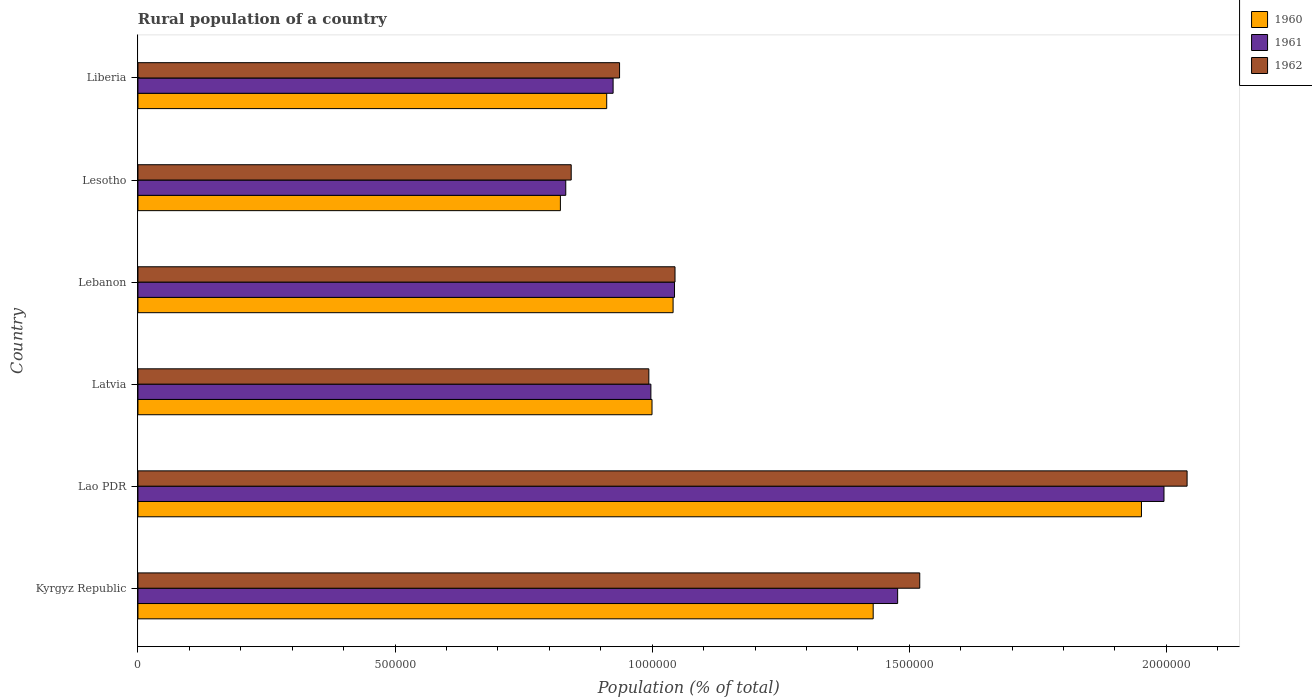Are the number of bars per tick equal to the number of legend labels?
Offer a very short reply. Yes. What is the label of the 4th group of bars from the top?
Provide a succinct answer. Latvia. In how many cases, is the number of bars for a given country not equal to the number of legend labels?
Your answer should be compact. 0. What is the rural population in 1960 in Lesotho?
Your answer should be compact. 8.22e+05. Across all countries, what is the maximum rural population in 1962?
Ensure brevity in your answer.  2.04e+06. Across all countries, what is the minimum rural population in 1960?
Offer a terse response. 8.22e+05. In which country was the rural population in 1961 maximum?
Your answer should be very brief. Lao PDR. In which country was the rural population in 1961 minimum?
Keep it short and to the point. Lesotho. What is the total rural population in 1961 in the graph?
Provide a short and direct response. 7.27e+06. What is the difference between the rural population in 1961 in Kyrgyz Republic and that in Latvia?
Your response must be concise. 4.80e+05. What is the difference between the rural population in 1960 in Lesotho and the rural population in 1962 in Lao PDR?
Provide a short and direct response. -1.22e+06. What is the average rural population in 1960 per country?
Offer a very short reply. 1.19e+06. What is the difference between the rural population in 1961 and rural population in 1960 in Lao PDR?
Ensure brevity in your answer.  4.38e+04. What is the ratio of the rural population in 1960 in Kyrgyz Republic to that in Lebanon?
Your answer should be compact. 1.37. Is the rural population in 1962 in Kyrgyz Republic less than that in Lao PDR?
Offer a terse response. Yes. Is the difference between the rural population in 1961 in Lao PDR and Liberia greater than the difference between the rural population in 1960 in Lao PDR and Liberia?
Provide a short and direct response. Yes. What is the difference between the highest and the second highest rural population in 1961?
Your answer should be compact. 5.18e+05. What is the difference between the highest and the lowest rural population in 1961?
Your response must be concise. 1.16e+06. In how many countries, is the rural population in 1960 greater than the average rural population in 1960 taken over all countries?
Keep it short and to the point. 2. Is the sum of the rural population in 1961 in Kyrgyz Republic and Lebanon greater than the maximum rural population in 1962 across all countries?
Offer a very short reply. Yes. Is it the case that in every country, the sum of the rural population in 1961 and rural population in 1960 is greater than the rural population in 1962?
Your answer should be very brief. Yes. How many countries are there in the graph?
Your answer should be very brief. 6. What is the difference between two consecutive major ticks on the X-axis?
Offer a very short reply. 5.00e+05. Does the graph contain grids?
Offer a very short reply. No. How are the legend labels stacked?
Offer a very short reply. Vertical. What is the title of the graph?
Your response must be concise. Rural population of a country. Does "1972" appear as one of the legend labels in the graph?
Keep it short and to the point. No. What is the label or title of the X-axis?
Offer a terse response. Population (% of total). What is the Population (% of total) in 1960 in Kyrgyz Republic?
Your answer should be very brief. 1.43e+06. What is the Population (% of total) in 1961 in Kyrgyz Republic?
Offer a very short reply. 1.48e+06. What is the Population (% of total) in 1962 in Kyrgyz Republic?
Offer a very short reply. 1.52e+06. What is the Population (% of total) in 1960 in Lao PDR?
Keep it short and to the point. 1.95e+06. What is the Population (% of total) in 1961 in Lao PDR?
Offer a terse response. 2.00e+06. What is the Population (% of total) of 1962 in Lao PDR?
Ensure brevity in your answer.  2.04e+06. What is the Population (% of total) of 1960 in Latvia?
Offer a very short reply. 1.00e+06. What is the Population (% of total) of 1961 in Latvia?
Your response must be concise. 9.97e+05. What is the Population (% of total) in 1962 in Latvia?
Offer a very short reply. 9.94e+05. What is the Population (% of total) of 1960 in Lebanon?
Ensure brevity in your answer.  1.04e+06. What is the Population (% of total) of 1961 in Lebanon?
Ensure brevity in your answer.  1.04e+06. What is the Population (% of total) in 1962 in Lebanon?
Keep it short and to the point. 1.04e+06. What is the Population (% of total) of 1960 in Lesotho?
Your answer should be very brief. 8.22e+05. What is the Population (% of total) in 1961 in Lesotho?
Your answer should be very brief. 8.32e+05. What is the Population (% of total) of 1962 in Lesotho?
Your answer should be very brief. 8.43e+05. What is the Population (% of total) in 1960 in Liberia?
Provide a succinct answer. 9.12e+05. What is the Population (% of total) in 1961 in Liberia?
Offer a terse response. 9.24e+05. What is the Population (% of total) of 1962 in Liberia?
Offer a very short reply. 9.37e+05. Across all countries, what is the maximum Population (% of total) in 1960?
Offer a terse response. 1.95e+06. Across all countries, what is the maximum Population (% of total) of 1961?
Provide a short and direct response. 2.00e+06. Across all countries, what is the maximum Population (% of total) of 1962?
Your answer should be very brief. 2.04e+06. Across all countries, what is the minimum Population (% of total) of 1960?
Offer a terse response. 8.22e+05. Across all countries, what is the minimum Population (% of total) in 1961?
Offer a very short reply. 8.32e+05. Across all countries, what is the minimum Population (% of total) in 1962?
Provide a short and direct response. 8.43e+05. What is the total Population (% of total) in 1960 in the graph?
Your response must be concise. 7.15e+06. What is the total Population (% of total) of 1961 in the graph?
Keep it short and to the point. 7.27e+06. What is the total Population (% of total) in 1962 in the graph?
Your response must be concise. 7.38e+06. What is the difference between the Population (% of total) in 1960 in Kyrgyz Republic and that in Lao PDR?
Your answer should be very brief. -5.22e+05. What is the difference between the Population (% of total) in 1961 in Kyrgyz Republic and that in Lao PDR?
Offer a terse response. -5.18e+05. What is the difference between the Population (% of total) of 1962 in Kyrgyz Republic and that in Lao PDR?
Offer a terse response. -5.20e+05. What is the difference between the Population (% of total) in 1960 in Kyrgyz Republic and that in Latvia?
Provide a succinct answer. 4.30e+05. What is the difference between the Population (% of total) in 1961 in Kyrgyz Republic and that in Latvia?
Offer a terse response. 4.80e+05. What is the difference between the Population (% of total) of 1962 in Kyrgyz Republic and that in Latvia?
Give a very brief answer. 5.27e+05. What is the difference between the Population (% of total) in 1960 in Kyrgyz Republic and that in Lebanon?
Your answer should be compact. 3.89e+05. What is the difference between the Population (% of total) in 1961 in Kyrgyz Republic and that in Lebanon?
Give a very brief answer. 4.34e+05. What is the difference between the Population (% of total) in 1962 in Kyrgyz Republic and that in Lebanon?
Your answer should be very brief. 4.76e+05. What is the difference between the Population (% of total) of 1960 in Kyrgyz Republic and that in Lesotho?
Your response must be concise. 6.08e+05. What is the difference between the Population (% of total) in 1961 in Kyrgyz Republic and that in Lesotho?
Provide a succinct answer. 6.45e+05. What is the difference between the Population (% of total) in 1962 in Kyrgyz Republic and that in Lesotho?
Your answer should be compact. 6.78e+05. What is the difference between the Population (% of total) in 1960 in Kyrgyz Republic and that in Liberia?
Your answer should be very brief. 5.18e+05. What is the difference between the Population (% of total) in 1961 in Kyrgyz Republic and that in Liberia?
Provide a succinct answer. 5.53e+05. What is the difference between the Population (% of total) in 1962 in Kyrgyz Republic and that in Liberia?
Make the answer very short. 5.84e+05. What is the difference between the Population (% of total) in 1960 in Lao PDR and that in Latvia?
Offer a terse response. 9.52e+05. What is the difference between the Population (% of total) in 1961 in Lao PDR and that in Latvia?
Offer a terse response. 9.98e+05. What is the difference between the Population (% of total) of 1962 in Lao PDR and that in Latvia?
Your answer should be compact. 1.05e+06. What is the difference between the Population (% of total) of 1960 in Lao PDR and that in Lebanon?
Provide a short and direct response. 9.11e+05. What is the difference between the Population (% of total) of 1961 in Lao PDR and that in Lebanon?
Provide a short and direct response. 9.52e+05. What is the difference between the Population (% of total) of 1962 in Lao PDR and that in Lebanon?
Give a very brief answer. 9.96e+05. What is the difference between the Population (% of total) of 1960 in Lao PDR and that in Lesotho?
Provide a succinct answer. 1.13e+06. What is the difference between the Population (% of total) in 1961 in Lao PDR and that in Lesotho?
Your answer should be very brief. 1.16e+06. What is the difference between the Population (% of total) in 1962 in Lao PDR and that in Lesotho?
Provide a succinct answer. 1.20e+06. What is the difference between the Population (% of total) in 1960 in Lao PDR and that in Liberia?
Your answer should be very brief. 1.04e+06. What is the difference between the Population (% of total) in 1961 in Lao PDR and that in Liberia?
Keep it short and to the point. 1.07e+06. What is the difference between the Population (% of total) in 1962 in Lao PDR and that in Liberia?
Give a very brief answer. 1.10e+06. What is the difference between the Population (% of total) in 1960 in Latvia and that in Lebanon?
Make the answer very short. -4.10e+04. What is the difference between the Population (% of total) of 1961 in Latvia and that in Lebanon?
Ensure brevity in your answer.  -4.60e+04. What is the difference between the Population (% of total) of 1962 in Latvia and that in Lebanon?
Offer a terse response. -5.09e+04. What is the difference between the Population (% of total) in 1960 in Latvia and that in Lesotho?
Give a very brief answer. 1.78e+05. What is the difference between the Population (% of total) in 1961 in Latvia and that in Lesotho?
Offer a very short reply. 1.66e+05. What is the difference between the Population (% of total) of 1962 in Latvia and that in Lesotho?
Make the answer very short. 1.51e+05. What is the difference between the Population (% of total) in 1960 in Latvia and that in Liberia?
Keep it short and to the point. 8.81e+04. What is the difference between the Population (% of total) in 1961 in Latvia and that in Liberia?
Your answer should be very brief. 7.35e+04. What is the difference between the Population (% of total) of 1962 in Latvia and that in Liberia?
Give a very brief answer. 5.69e+04. What is the difference between the Population (% of total) of 1960 in Lebanon and that in Lesotho?
Offer a terse response. 2.19e+05. What is the difference between the Population (% of total) of 1961 in Lebanon and that in Lesotho?
Keep it short and to the point. 2.12e+05. What is the difference between the Population (% of total) of 1962 in Lebanon and that in Lesotho?
Make the answer very short. 2.02e+05. What is the difference between the Population (% of total) in 1960 in Lebanon and that in Liberia?
Offer a terse response. 1.29e+05. What is the difference between the Population (% of total) of 1961 in Lebanon and that in Liberia?
Ensure brevity in your answer.  1.19e+05. What is the difference between the Population (% of total) in 1962 in Lebanon and that in Liberia?
Give a very brief answer. 1.08e+05. What is the difference between the Population (% of total) in 1960 in Lesotho and that in Liberia?
Provide a short and direct response. -9.01e+04. What is the difference between the Population (% of total) of 1961 in Lesotho and that in Liberia?
Keep it short and to the point. -9.21e+04. What is the difference between the Population (% of total) in 1962 in Lesotho and that in Liberia?
Ensure brevity in your answer.  -9.40e+04. What is the difference between the Population (% of total) in 1960 in Kyrgyz Republic and the Population (% of total) in 1961 in Lao PDR?
Offer a terse response. -5.66e+05. What is the difference between the Population (% of total) in 1960 in Kyrgyz Republic and the Population (% of total) in 1962 in Lao PDR?
Ensure brevity in your answer.  -6.10e+05. What is the difference between the Population (% of total) of 1961 in Kyrgyz Republic and the Population (% of total) of 1962 in Lao PDR?
Offer a very short reply. -5.63e+05. What is the difference between the Population (% of total) of 1960 in Kyrgyz Republic and the Population (% of total) of 1961 in Latvia?
Give a very brief answer. 4.32e+05. What is the difference between the Population (% of total) of 1960 in Kyrgyz Republic and the Population (% of total) of 1962 in Latvia?
Offer a terse response. 4.36e+05. What is the difference between the Population (% of total) in 1961 in Kyrgyz Republic and the Population (% of total) in 1962 in Latvia?
Offer a terse response. 4.84e+05. What is the difference between the Population (% of total) of 1960 in Kyrgyz Republic and the Population (% of total) of 1961 in Lebanon?
Make the answer very short. 3.86e+05. What is the difference between the Population (% of total) in 1960 in Kyrgyz Republic and the Population (% of total) in 1962 in Lebanon?
Your answer should be compact. 3.85e+05. What is the difference between the Population (% of total) in 1961 in Kyrgyz Republic and the Population (% of total) in 1962 in Lebanon?
Your answer should be very brief. 4.33e+05. What is the difference between the Population (% of total) of 1960 in Kyrgyz Republic and the Population (% of total) of 1961 in Lesotho?
Ensure brevity in your answer.  5.98e+05. What is the difference between the Population (% of total) of 1960 in Kyrgyz Republic and the Population (% of total) of 1962 in Lesotho?
Your response must be concise. 5.87e+05. What is the difference between the Population (% of total) of 1961 in Kyrgyz Republic and the Population (% of total) of 1962 in Lesotho?
Your answer should be very brief. 6.35e+05. What is the difference between the Population (% of total) of 1960 in Kyrgyz Republic and the Population (% of total) of 1961 in Liberia?
Your response must be concise. 5.06e+05. What is the difference between the Population (% of total) of 1960 in Kyrgyz Republic and the Population (% of total) of 1962 in Liberia?
Provide a succinct answer. 4.93e+05. What is the difference between the Population (% of total) in 1961 in Kyrgyz Republic and the Population (% of total) in 1962 in Liberia?
Offer a terse response. 5.41e+05. What is the difference between the Population (% of total) in 1960 in Lao PDR and the Population (% of total) in 1961 in Latvia?
Your answer should be compact. 9.54e+05. What is the difference between the Population (% of total) of 1960 in Lao PDR and the Population (% of total) of 1962 in Latvia?
Your answer should be compact. 9.58e+05. What is the difference between the Population (% of total) in 1961 in Lao PDR and the Population (% of total) in 1962 in Latvia?
Provide a succinct answer. 1.00e+06. What is the difference between the Population (% of total) in 1960 in Lao PDR and the Population (% of total) in 1961 in Lebanon?
Offer a terse response. 9.08e+05. What is the difference between the Population (% of total) of 1960 in Lao PDR and the Population (% of total) of 1962 in Lebanon?
Keep it short and to the point. 9.07e+05. What is the difference between the Population (% of total) of 1961 in Lao PDR and the Population (% of total) of 1962 in Lebanon?
Ensure brevity in your answer.  9.51e+05. What is the difference between the Population (% of total) of 1960 in Lao PDR and the Population (% of total) of 1961 in Lesotho?
Give a very brief answer. 1.12e+06. What is the difference between the Population (% of total) of 1960 in Lao PDR and the Population (% of total) of 1962 in Lesotho?
Keep it short and to the point. 1.11e+06. What is the difference between the Population (% of total) in 1961 in Lao PDR and the Population (% of total) in 1962 in Lesotho?
Make the answer very short. 1.15e+06. What is the difference between the Population (% of total) of 1960 in Lao PDR and the Population (% of total) of 1961 in Liberia?
Your answer should be compact. 1.03e+06. What is the difference between the Population (% of total) in 1960 in Lao PDR and the Population (% of total) in 1962 in Liberia?
Ensure brevity in your answer.  1.01e+06. What is the difference between the Population (% of total) in 1961 in Lao PDR and the Population (% of total) in 1962 in Liberia?
Your response must be concise. 1.06e+06. What is the difference between the Population (% of total) in 1960 in Latvia and the Population (% of total) in 1961 in Lebanon?
Offer a very short reply. -4.38e+04. What is the difference between the Population (% of total) in 1960 in Latvia and the Population (% of total) in 1962 in Lebanon?
Make the answer very short. -4.47e+04. What is the difference between the Population (% of total) of 1961 in Latvia and the Population (% of total) of 1962 in Lebanon?
Give a very brief answer. -4.69e+04. What is the difference between the Population (% of total) of 1960 in Latvia and the Population (% of total) of 1961 in Lesotho?
Keep it short and to the point. 1.68e+05. What is the difference between the Population (% of total) in 1960 in Latvia and the Population (% of total) in 1962 in Lesotho?
Offer a terse response. 1.57e+05. What is the difference between the Population (% of total) in 1961 in Latvia and the Population (% of total) in 1962 in Lesotho?
Keep it short and to the point. 1.55e+05. What is the difference between the Population (% of total) of 1960 in Latvia and the Population (% of total) of 1961 in Liberia?
Make the answer very short. 7.56e+04. What is the difference between the Population (% of total) of 1960 in Latvia and the Population (% of total) of 1962 in Liberia?
Offer a terse response. 6.31e+04. What is the difference between the Population (% of total) in 1961 in Latvia and the Population (% of total) in 1962 in Liberia?
Offer a very short reply. 6.09e+04. What is the difference between the Population (% of total) in 1960 in Lebanon and the Population (% of total) in 1961 in Lesotho?
Your answer should be compact. 2.09e+05. What is the difference between the Population (% of total) of 1960 in Lebanon and the Population (% of total) of 1962 in Lesotho?
Give a very brief answer. 1.98e+05. What is the difference between the Population (% of total) in 1961 in Lebanon and the Population (% of total) in 1962 in Lesotho?
Your answer should be compact. 2.01e+05. What is the difference between the Population (% of total) in 1960 in Lebanon and the Population (% of total) in 1961 in Liberia?
Ensure brevity in your answer.  1.17e+05. What is the difference between the Population (% of total) in 1960 in Lebanon and the Population (% of total) in 1962 in Liberia?
Provide a succinct answer. 1.04e+05. What is the difference between the Population (% of total) in 1961 in Lebanon and the Population (% of total) in 1962 in Liberia?
Your response must be concise. 1.07e+05. What is the difference between the Population (% of total) in 1960 in Lesotho and the Population (% of total) in 1961 in Liberia?
Make the answer very short. -1.03e+05. What is the difference between the Population (% of total) of 1960 in Lesotho and the Population (% of total) of 1962 in Liberia?
Provide a succinct answer. -1.15e+05. What is the difference between the Population (% of total) of 1961 in Lesotho and the Population (% of total) of 1962 in Liberia?
Keep it short and to the point. -1.05e+05. What is the average Population (% of total) in 1960 per country?
Your answer should be very brief. 1.19e+06. What is the average Population (% of total) of 1961 per country?
Give a very brief answer. 1.21e+06. What is the average Population (% of total) in 1962 per country?
Give a very brief answer. 1.23e+06. What is the difference between the Population (% of total) in 1960 and Population (% of total) in 1961 in Kyrgyz Republic?
Keep it short and to the point. -4.76e+04. What is the difference between the Population (% of total) in 1960 and Population (% of total) in 1962 in Kyrgyz Republic?
Offer a terse response. -9.06e+04. What is the difference between the Population (% of total) of 1961 and Population (% of total) of 1962 in Kyrgyz Republic?
Provide a succinct answer. -4.30e+04. What is the difference between the Population (% of total) in 1960 and Population (% of total) in 1961 in Lao PDR?
Your answer should be very brief. -4.38e+04. What is the difference between the Population (% of total) in 1960 and Population (% of total) in 1962 in Lao PDR?
Offer a very short reply. -8.88e+04. What is the difference between the Population (% of total) of 1961 and Population (% of total) of 1962 in Lao PDR?
Provide a succinct answer. -4.49e+04. What is the difference between the Population (% of total) in 1960 and Population (% of total) in 1961 in Latvia?
Ensure brevity in your answer.  2193. What is the difference between the Population (% of total) of 1960 and Population (% of total) of 1962 in Latvia?
Offer a terse response. 6165. What is the difference between the Population (% of total) in 1961 and Population (% of total) in 1962 in Latvia?
Your answer should be compact. 3972. What is the difference between the Population (% of total) of 1960 and Population (% of total) of 1961 in Lebanon?
Give a very brief answer. -2785. What is the difference between the Population (% of total) of 1960 and Population (% of total) of 1962 in Lebanon?
Provide a short and direct response. -3757. What is the difference between the Population (% of total) in 1961 and Population (% of total) in 1962 in Lebanon?
Your response must be concise. -972. What is the difference between the Population (% of total) in 1960 and Population (% of total) in 1961 in Lesotho?
Your response must be concise. -1.04e+04. What is the difference between the Population (% of total) of 1960 and Population (% of total) of 1962 in Lesotho?
Provide a short and direct response. -2.10e+04. What is the difference between the Population (% of total) of 1961 and Population (% of total) of 1962 in Lesotho?
Your response must be concise. -1.06e+04. What is the difference between the Population (% of total) in 1960 and Population (% of total) in 1961 in Liberia?
Ensure brevity in your answer.  -1.25e+04. What is the difference between the Population (% of total) in 1960 and Population (% of total) in 1962 in Liberia?
Provide a succinct answer. -2.50e+04. What is the difference between the Population (% of total) in 1961 and Population (% of total) in 1962 in Liberia?
Your answer should be very brief. -1.25e+04. What is the ratio of the Population (% of total) of 1960 in Kyrgyz Republic to that in Lao PDR?
Your answer should be very brief. 0.73. What is the ratio of the Population (% of total) in 1961 in Kyrgyz Republic to that in Lao PDR?
Ensure brevity in your answer.  0.74. What is the ratio of the Population (% of total) in 1962 in Kyrgyz Republic to that in Lao PDR?
Your answer should be very brief. 0.75. What is the ratio of the Population (% of total) of 1960 in Kyrgyz Republic to that in Latvia?
Offer a terse response. 1.43. What is the ratio of the Population (% of total) in 1961 in Kyrgyz Republic to that in Latvia?
Keep it short and to the point. 1.48. What is the ratio of the Population (% of total) in 1962 in Kyrgyz Republic to that in Latvia?
Ensure brevity in your answer.  1.53. What is the ratio of the Population (% of total) in 1960 in Kyrgyz Republic to that in Lebanon?
Provide a short and direct response. 1.37. What is the ratio of the Population (% of total) of 1961 in Kyrgyz Republic to that in Lebanon?
Make the answer very short. 1.42. What is the ratio of the Population (% of total) in 1962 in Kyrgyz Republic to that in Lebanon?
Make the answer very short. 1.46. What is the ratio of the Population (% of total) in 1960 in Kyrgyz Republic to that in Lesotho?
Your answer should be very brief. 1.74. What is the ratio of the Population (% of total) in 1961 in Kyrgyz Republic to that in Lesotho?
Offer a terse response. 1.78. What is the ratio of the Population (% of total) in 1962 in Kyrgyz Republic to that in Lesotho?
Make the answer very short. 1.8. What is the ratio of the Population (% of total) in 1960 in Kyrgyz Republic to that in Liberia?
Provide a short and direct response. 1.57. What is the ratio of the Population (% of total) in 1961 in Kyrgyz Republic to that in Liberia?
Your response must be concise. 1.6. What is the ratio of the Population (% of total) of 1962 in Kyrgyz Republic to that in Liberia?
Provide a short and direct response. 1.62. What is the ratio of the Population (% of total) in 1960 in Lao PDR to that in Latvia?
Your answer should be compact. 1.95. What is the ratio of the Population (% of total) in 1961 in Lao PDR to that in Latvia?
Make the answer very short. 2. What is the ratio of the Population (% of total) in 1962 in Lao PDR to that in Latvia?
Your answer should be very brief. 2.05. What is the ratio of the Population (% of total) of 1960 in Lao PDR to that in Lebanon?
Give a very brief answer. 1.88. What is the ratio of the Population (% of total) in 1961 in Lao PDR to that in Lebanon?
Give a very brief answer. 1.91. What is the ratio of the Population (% of total) of 1962 in Lao PDR to that in Lebanon?
Your response must be concise. 1.95. What is the ratio of the Population (% of total) of 1960 in Lao PDR to that in Lesotho?
Your response must be concise. 2.38. What is the ratio of the Population (% of total) in 1961 in Lao PDR to that in Lesotho?
Offer a very short reply. 2.4. What is the ratio of the Population (% of total) of 1962 in Lao PDR to that in Lesotho?
Offer a terse response. 2.42. What is the ratio of the Population (% of total) of 1960 in Lao PDR to that in Liberia?
Offer a terse response. 2.14. What is the ratio of the Population (% of total) in 1961 in Lao PDR to that in Liberia?
Make the answer very short. 2.16. What is the ratio of the Population (% of total) of 1962 in Lao PDR to that in Liberia?
Make the answer very short. 2.18. What is the ratio of the Population (% of total) of 1960 in Latvia to that in Lebanon?
Make the answer very short. 0.96. What is the ratio of the Population (% of total) of 1961 in Latvia to that in Lebanon?
Make the answer very short. 0.96. What is the ratio of the Population (% of total) in 1962 in Latvia to that in Lebanon?
Ensure brevity in your answer.  0.95. What is the ratio of the Population (% of total) in 1960 in Latvia to that in Lesotho?
Keep it short and to the point. 1.22. What is the ratio of the Population (% of total) in 1961 in Latvia to that in Lesotho?
Your answer should be very brief. 1.2. What is the ratio of the Population (% of total) in 1962 in Latvia to that in Lesotho?
Your answer should be very brief. 1.18. What is the ratio of the Population (% of total) of 1960 in Latvia to that in Liberia?
Make the answer very short. 1.1. What is the ratio of the Population (% of total) of 1961 in Latvia to that in Liberia?
Give a very brief answer. 1.08. What is the ratio of the Population (% of total) of 1962 in Latvia to that in Liberia?
Your answer should be compact. 1.06. What is the ratio of the Population (% of total) in 1960 in Lebanon to that in Lesotho?
Provide a succinct answer. 1.27. What is the ratio of the Population (% of total) in 1961 in Lebanon to that in Lesotho?
Ensure brevity in your answer.  1.25. What is the ratio of the Population (% of total) of 1962 in Lebanon to that in Lesotho?
Offer a very short reply. 1.24. What is the ratio of the Population (% of total) in 1960 in Lebanon to that in Liberia?
Offer a terse response. 1.14. What is the ratio of the Population (% of total) in 1961 in Lebanon to that in Liberia?
Offer a very short reply. 1.13. What is the ratio of the Population (% of total) in 1962 in Lebanon to that in Liberia?
Provide a succinct answer. 1.12. What is the ratio of the Population (% of total) in 1960 in Lesotho to that in Liberia?
Keep it short and to the point. 0.9. What is the ratio of the Population (% of total) of 1961 in Lesotho to that in Liberia?
Offer a very short reply. 0.9. What is the ratio of the Population (% of total) in 1962 in Lesotho to that in Liberia?
Your answer should be very brief. 0.9. What is the difference between the highest and the second highest Population (% of total) in 1960?
Your answer should be compact. 5.22e+05. What is the difference between the highest and the second highest Population (% of total) of 1961?
Make the answer very short. 5.18e+05. What is the difference between the highest and the second highest Population (% of total) of 1962?
Give a very brief answer. 5.20e+05. What is the difference between the highest and the lowest Population (% of total) in 1960?
Your answer should be compact. 1.13e+06. What is the difference between the highest and the lowest Population (% of total) of 1961?
Provide a succinct answer. 1.16e+06. What is the difference between the highest and the lowest Population (% of total) in 1962?
Make the answer very short. 1.20e+06. 